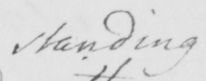What is written in this line of handwriting? standing 